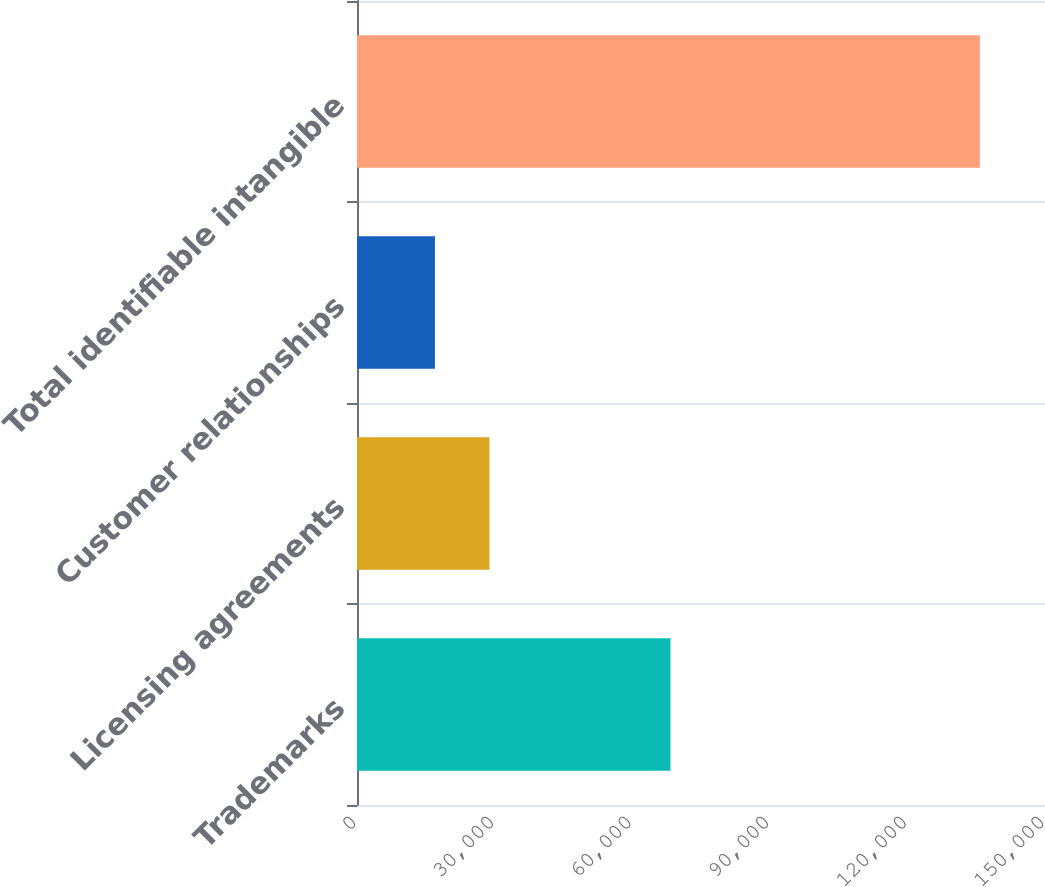<chart> <loc_0><loc_0><loc_500><loc_500><bar_chart><fcel>Trademarks<fcel>Licensing agreements<fcel>Customer relationships<fcel>Total identifiable intangible<nl><fcel>68344<fcel>28874.9<fcel>16994<fcel>135803<nl></chart> 